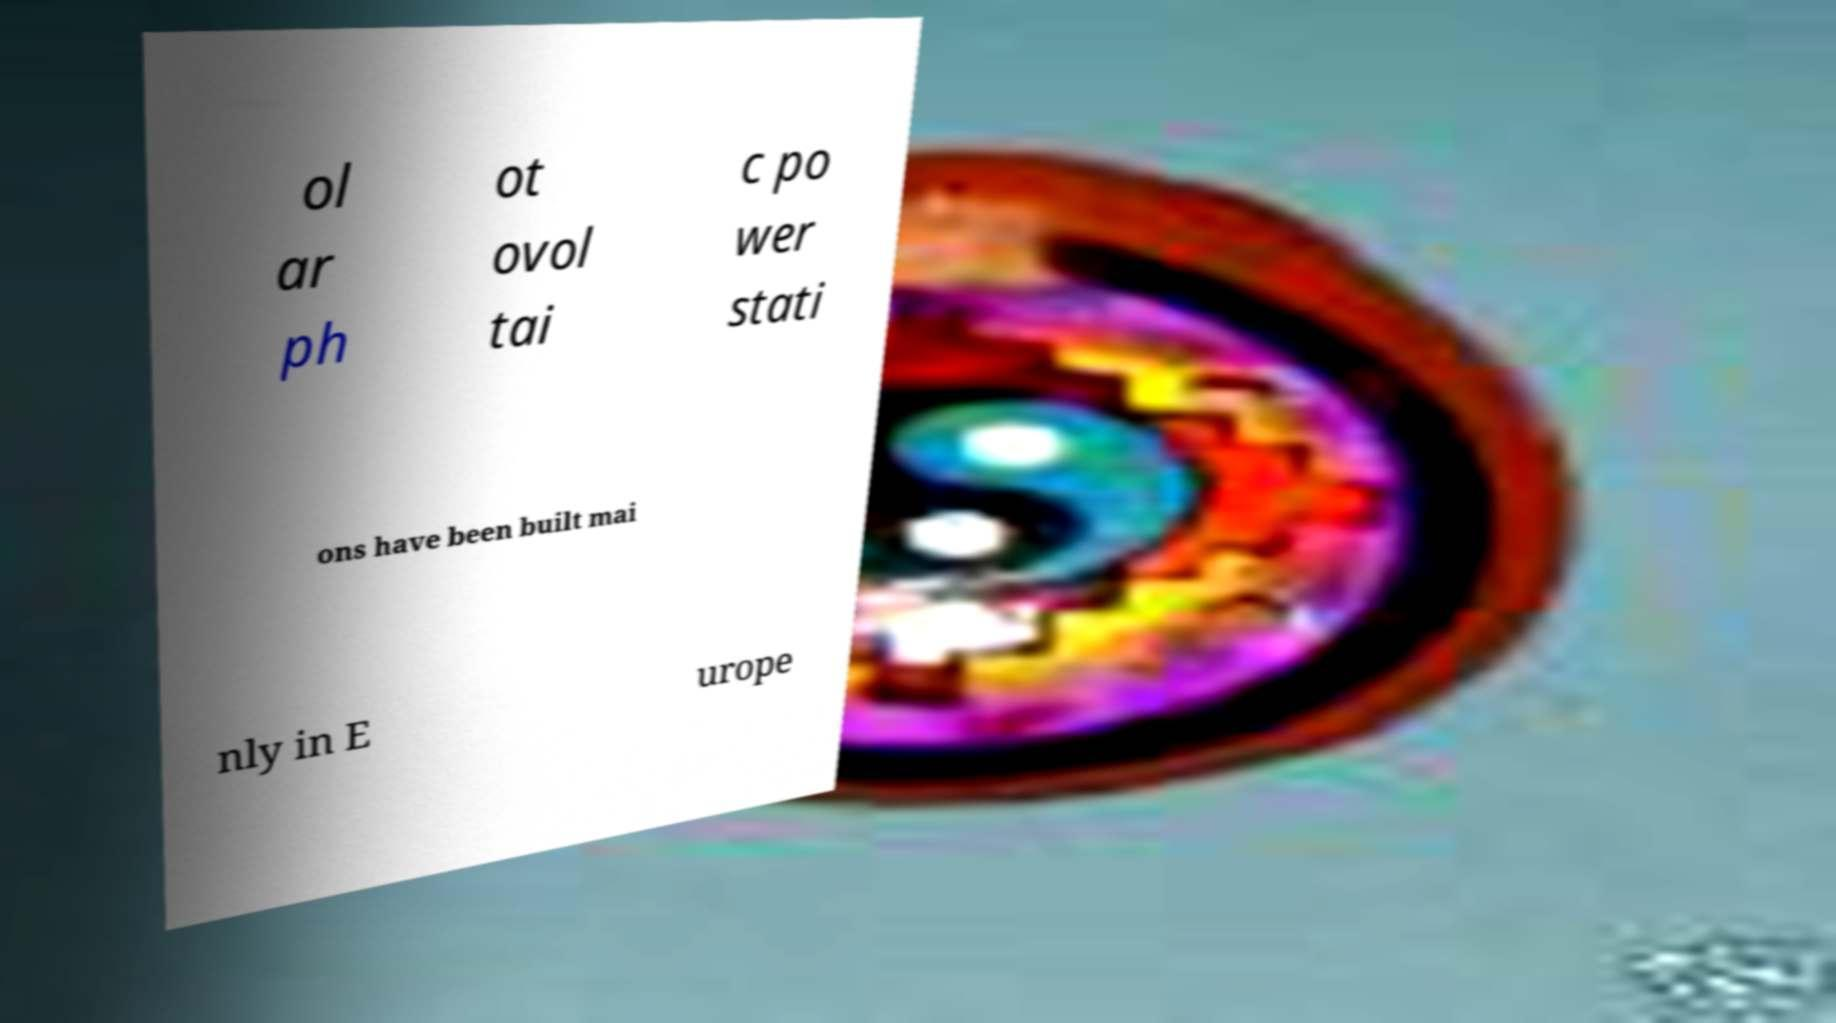What messages or text are displayed in this image? I need them in a readable, typed format. ol ar ph ot ovol tai c po wer stati ons have been built mai nly in E urope 